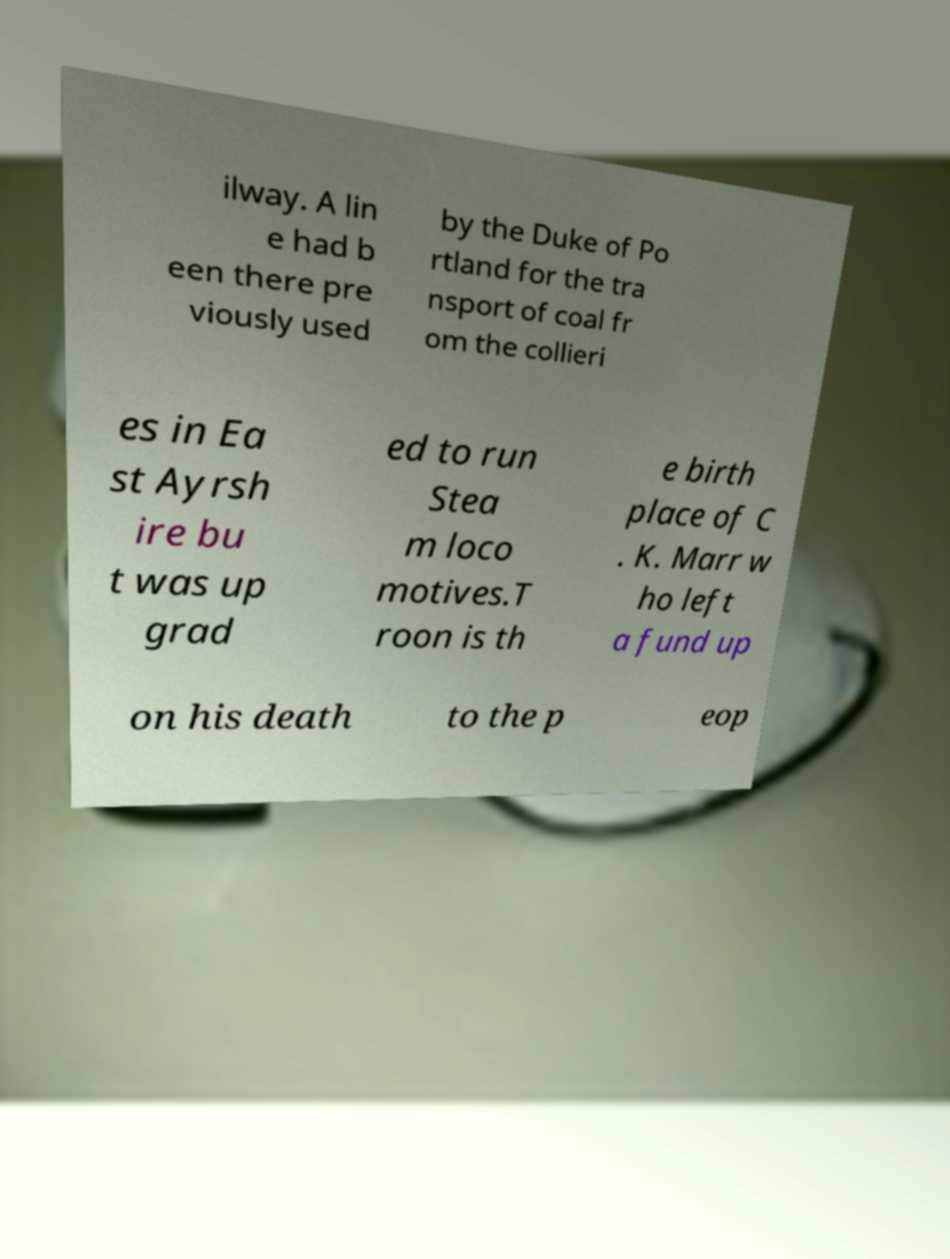There's text embedded in this image that I need extracted. Can you transcribe it verbatim? ilway. A lin e had b een there pre viously used by the Duke of Po rtland for the tra nsport of coal fr om the collieri es in Ea st Ayrsh ire bu t was up grad ed to run Stea m loco motives.T roon is th e birth place of C . K. Marr w ho left a fund up on his death to the p eop 